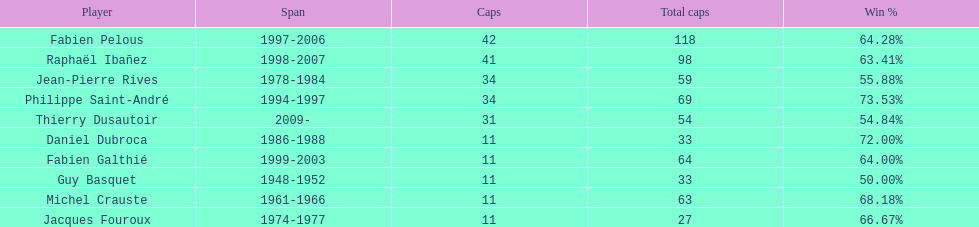How long did michel crauste serve as captain? 1961-1966. 